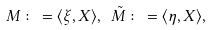<formula> <loc_0><loc_0><loc_500><loc_500>M \colon = \langle \xi , X \rangle , \ \tilde { M } \colon = \langle \eta , X \rangle ,</formula> 